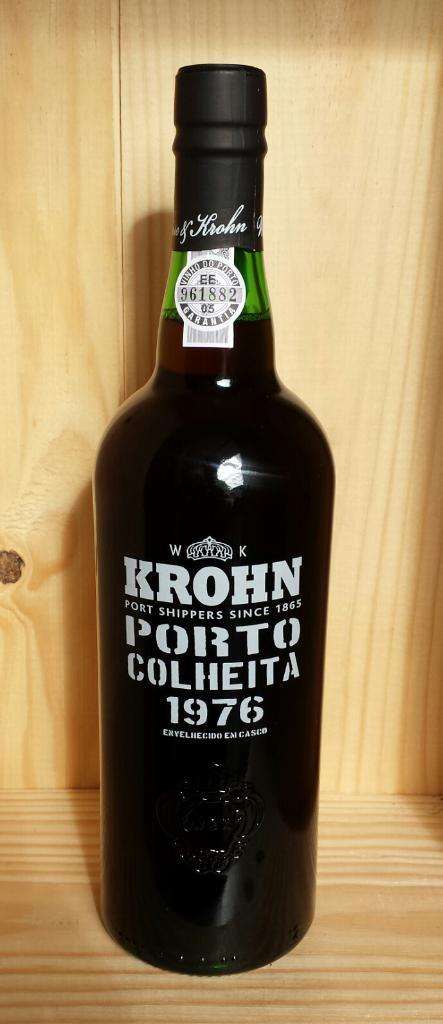What year was this bottled in?
Offer a terse response. 1976. What word is written below edelherb on the neck of the bottle?
Provide a short and direct response. Krohn. 